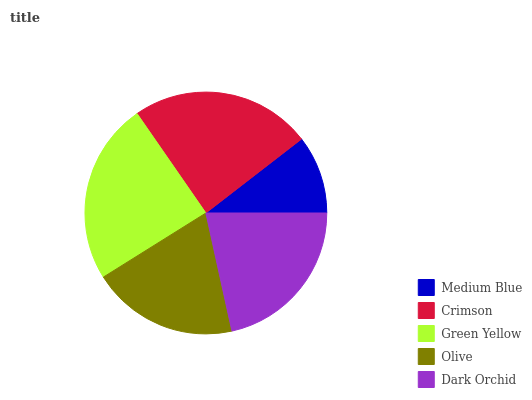Is Medium Blue the minimum?
Answer yes or no. Yes. Is Green Yellow the maximum?
Answer yes or no. Yes. Is Crimson the minimum?
Answer yes or no. No. Is Crimson the maximum?
Answer yes or no. No. Is Crimson greater than Medium Blue?
Answer yes or no. Yes. Is Medium Blue less than Crimson?
Answer yes or no. Yes. Is Medium Blue greater than Crimson?
Answer yes or no. No. Is Crimson less than Medium Blue?
Answer yes or no. No. Is Dark Orchid the high median?
Answer yes or no. Yes. Is Dark Orchid the low median?
Answer yes or no. Yes. Is Green Yellow the high median?
Answer yes or no. No. Is Green Yellow the low median?
Answer yes or no. No. 